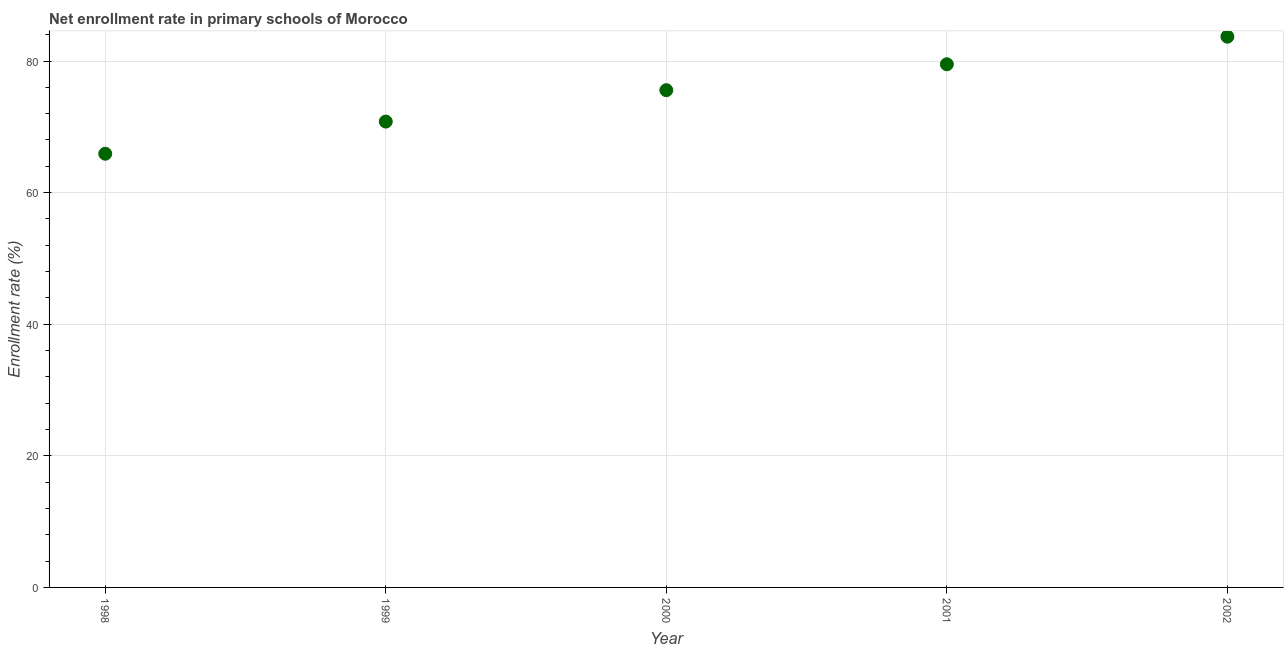What is the net enrollment rate in primary schools in 2001?
Offer a very short reply. 79.5. Across all years, what is the maximum net enrollment rate in primary schools?
Make the answer very short. 83.7. Across all years, what is the minimum net enrollment rate in primary schools?
Your answer should be compact. 65.91. What is the sum of the net enrollment rate in primary schools?
Ensure brevity in your answer.  375.47. What is the difference between the net enrollment rate in primary schools in 2000 and 2001?
Your response must be concise. -3.94. What is the average net enrollment rate in primary schools per year?
Your answer should be compact. 75.09. What is the median net enrollment rate in primary schools?
Your response must be concise. 75.57. Do a majority of the years between 1998 and 2001 (inclusive) have net enrollment rate in primary schools greater than 4 %?
Keep it short and to the point. Yes. What is the ratio of the net enrollment rate in primary schools in 1998 to that in 2002?
Ensure brevity in your answer.  0.79. What is the difference between the highest and the second highest net enrollment rate in primary schools?
Ensure brevity in your answer.  4.19. Is the sum of the net enrollment rate in primary schools in 1998 and 1999 greater than the maximum net enrollment rate in primary schools across all years?
Ensure brevity in your answer.  Yes. What is the difference between the highest and the lowest net enrollment rate in primary schools?
Ensure brevity in your answer.  17.79. Does the net enrollment rate in primary schools monotonically increase over the years?
Provide a succinct answer. Yes. How many years are there in the graph?
Keep it short and to the point. 5. Does the graph contain any zero values?
Keep it short and to the point. No. What is the title of the graph?
Provide a short and direct response. Net enrollment rate in primary schools of Morocco. What is the label or title of the Y-axis?
Your response must be concise. Enrollment rate (%). What is the Enrollment rate (%) in 1998?
Your answer should be compact. 65.91. What is the Enrollment rate (%) in 1999?
Your response must be concise. 70.79. What is the Enrollment rate (%) in 2000?
Provide a short and direct response. 75.57. What is the Enrollment rate (%) in 2001?
Your answer should be very brief. 79.5. What is the Enrollment rate (%) in 2002?
Your answer should be very brief. 83.7. What is the difference between the Enrollment rate (%) in 1998 and 1999?
Provide a succinct answer. -4.88. What is the difference between the Enrollment rate (%) in 1998 and 2000?
Offer a terse response. -9.66. What is the difference between the Enrollment rate (%) in 1998 and 2001?
Give a very brief answer. -13.6. What is the difference between the Enrollment rate (%) in 1998 and 2002?
Your answer should be compact. -17.79. What is the difference between the Enrollment rate (%) in 1999 and 2000?
Give a very brief answer. -4.77. What is the difference between the Enrollment rate (%) in 1999 and 2001?
Provide a short and direct response. -8.71. What is the difference between the Enrollment rate (%) in 1999 and 2002?
Offer a very short reply. -12.9. What is the difference between the Enrollment rate (%) in 2000 and 2001?
Your answer should be compact. -3.94. What is the difference between the Enrollment rate (%) in 2000 and 2002?
Give a very brief answer. -8.13. What is the difference between the Enrollment rate (%) in 2001 and 2002?
Provide a short and direct response. -4.19. What is the ratio of the Enrollment rate (%) in 1998 to that in 2000?
Your response must be concise. 0.87. What is the ratio of the Enrollment rate (%) in 1998 to that in 2001?
Offer a very short reply. 0.83. What is the ratio of the Enrollment rate (%) in 1998 to that in 2002?
Give a very brief answer. 0.79. What is the ratio of the Enrollment rate (%) in 1999 to that in 2000?
Provide a short and direct response. 0.94. What is the ratio of the Enrollment rate (%) in 1999 to that in 2001?
Make the answer very short. 0.89. What is the ratio of the Enrollment rate (%) in 1999 to that in 2002?
Ensure brevity in your answer.  0.85. What is the ratio of the Enrollment rate (%) in 2000 to that in 2002?
Offer a terse response. 0.9. What is the ratio of the Enrollment rate (%) in 2001 to that in 2002?
Ensure brevity in your answer.  0.95. 